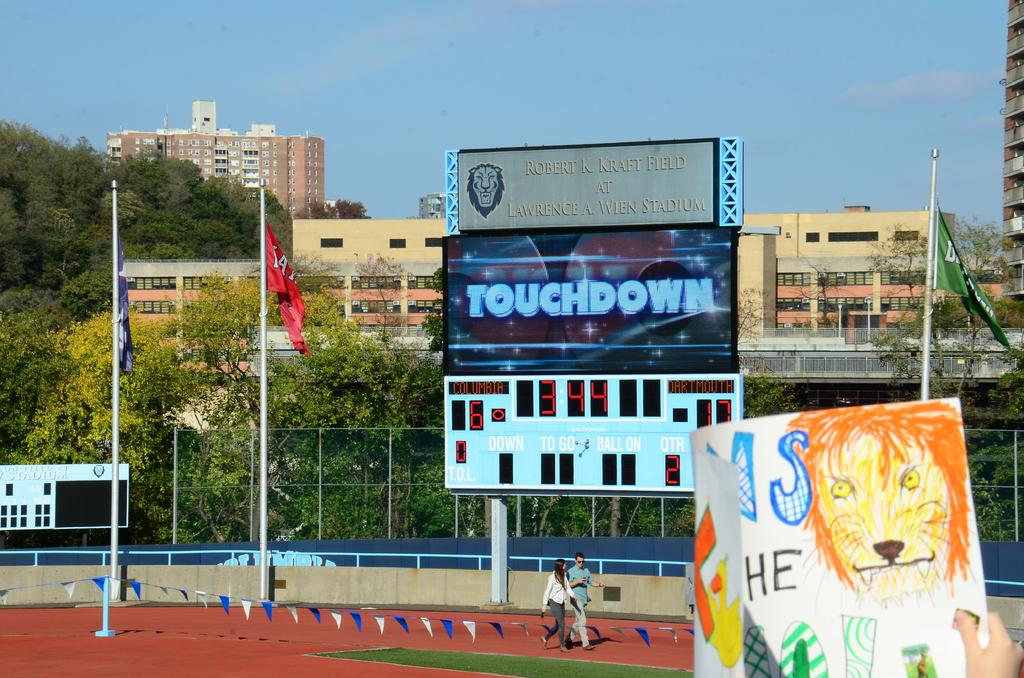<image>
Create a compact narrative representing the image presented. A football stadium big screen showing the text touchdown on it. 